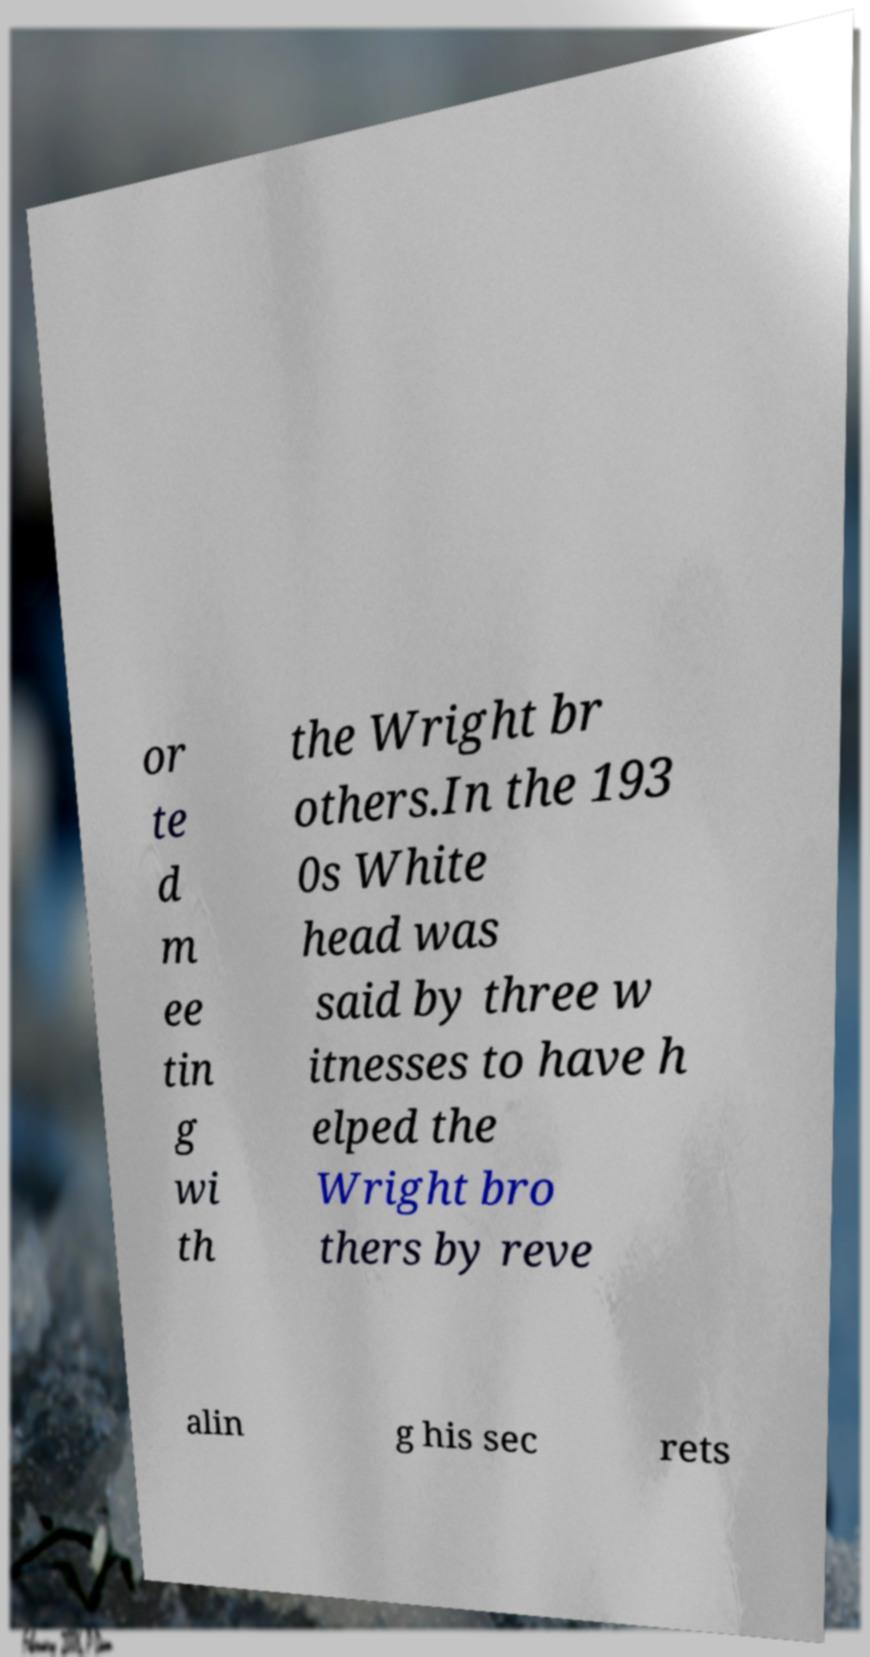There's text embedded in this image that I need extracted. Can you transcribe it verbatim? or te d m ee tin g wi th the Wright br others.In the 193 0s White head was said by three w itnesses to have h elped the Wright bro thers by reve alin g his sec rets 